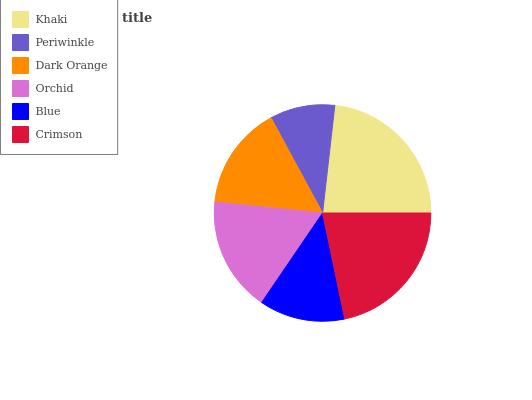Is Periwinkle the minimum?
Answer yes or no. Yes. Is Khaki the maximum?
Answer yes or no. Yes. Is Dark Orange the minimum?
Answer yes or no. No. Is Dark Orange the maximum?
Answer yes or no. No. Is Dark Orange greater than Periwinkle?
Answer yes or no. Yes. Is Periwinkle less than Dark Orange?
Answer yes or no. Yes. Is Periwinkle greater than Dark Orange?
Answer yes or no. No. Is Dark Orange less than Periwinkle?
Answer yes or no. No. Is Orchid the high median?
Answer yes or no. Yes. Is Dark Orange the low median?
Answer yes or no. Yes. Is Crimson the high median?
Answer yes or no. No. Is Blue the low median?
Answer yes or no. No. 